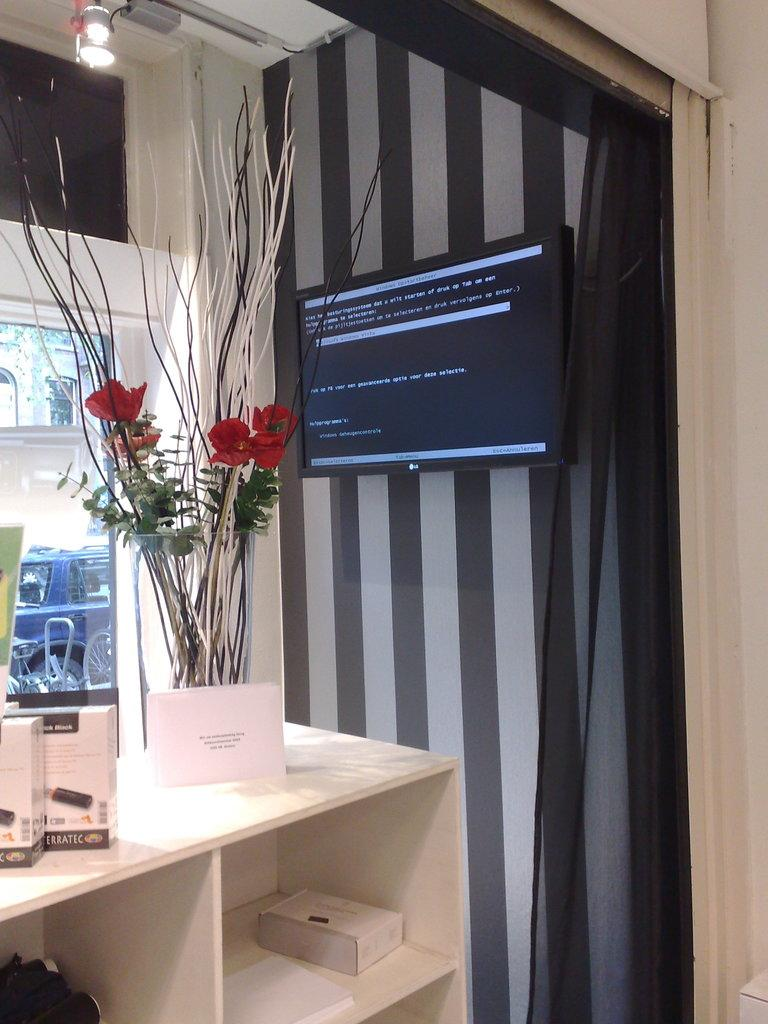What piece of furniture is present in the image? There is a table in the image. What is placed on the table? There is a flower vase and boxes on the table. What can be seen below the table? There are racks below the table. What electronic device is visible in the background? There is a television on the wall in the background. What other object can be seen in the background? There is a glass object in the background. What is the source of light in the background? There is a light source in the background. What letter does the flower vase spell out in the image? The flower vase does not spell out any letters in the image. What type of experience can be gained from the objects in the image? The objects in the image do not provide any specific experiences. 